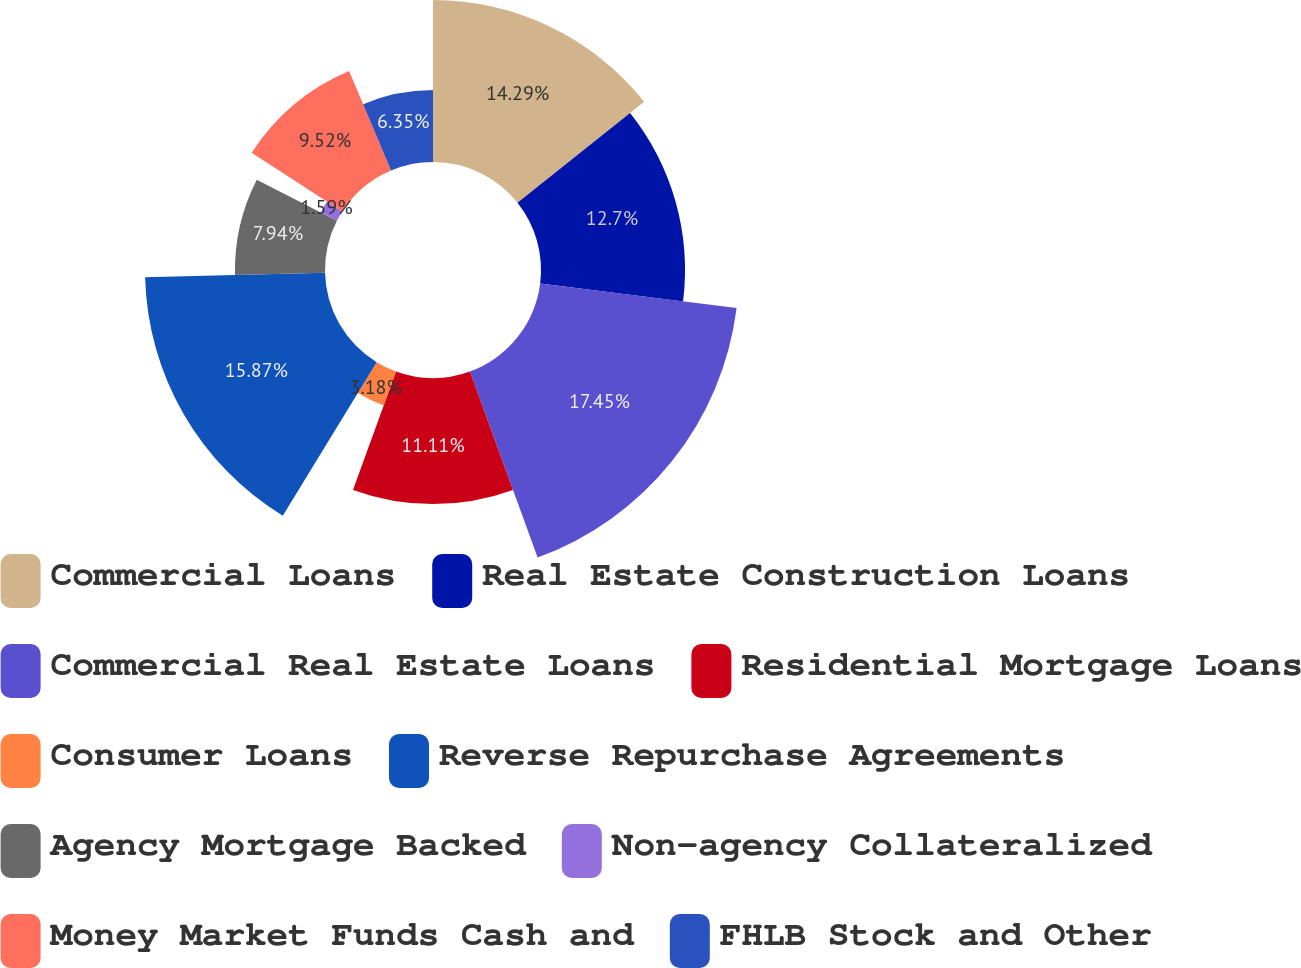<chart> <loc_0><loc_0><loc_500><loc_500><pie_chart><fcel>Commercial Loans<fcel>Real Estate Construction Loans<fcel>Commercial Real Estate Loans<fcel>Residential Mortgage Loans<fcel>Consumer Loans<fcel>Reverse Repurchase Agreements<fcel>Agency Mortgage Backed<fcel>Non-agency Collateralized<fcel>Money Market Funds Cash and<fcel>FHLB Stock and Other<nl><fcel>14.29%<fcel>12.7%<fcel>17.46%<fcel>11.11%<fcel>3.18%<fcel>15.87%<fcel>7.94%<fcel>1.59%<fcel>9.52%<fcel>6.35%<nl></chart> 